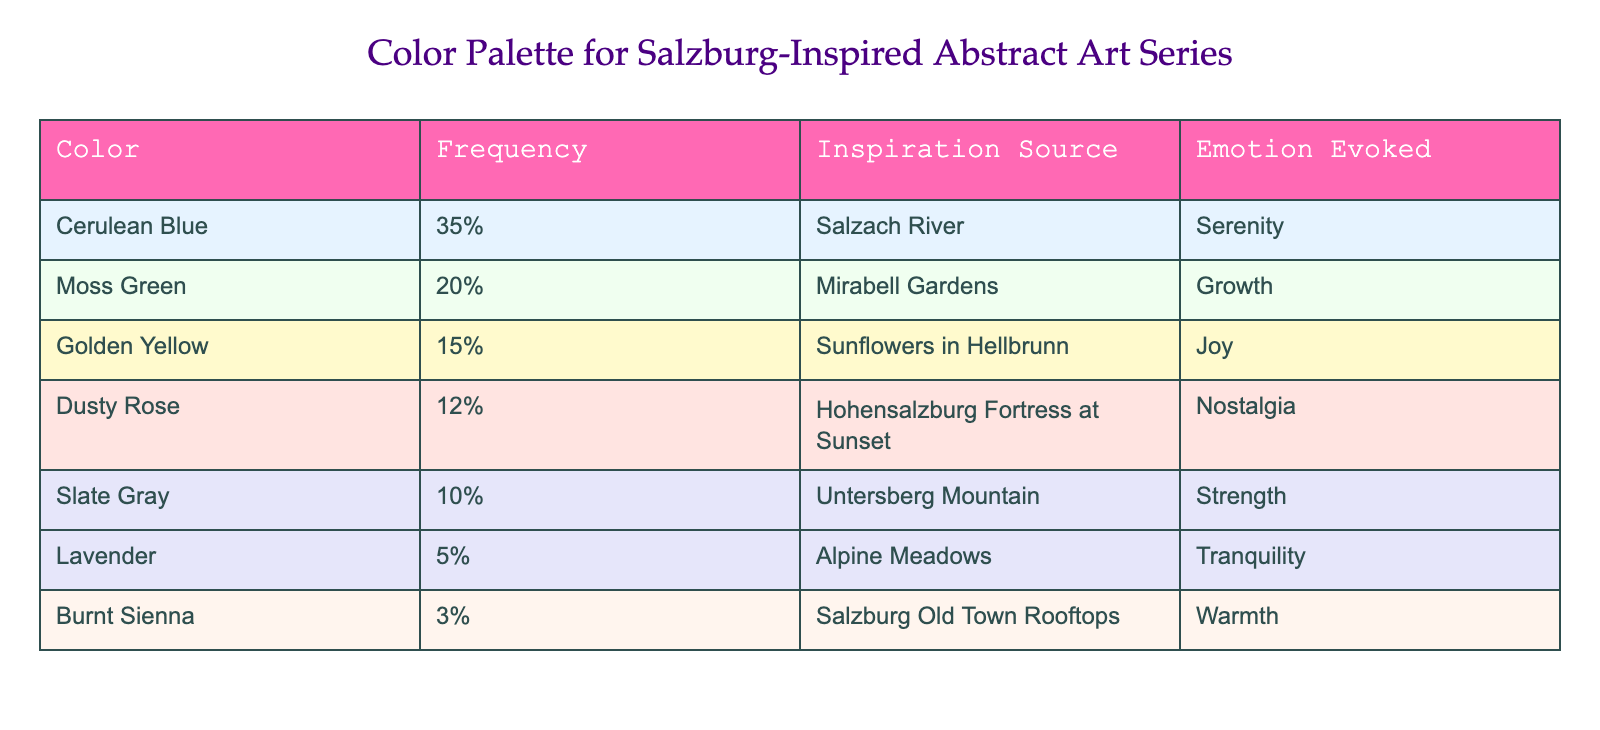What color occurs most frequently in the palette? Looking at the Frequency column, Cerulean Blue has the highest value at 35%.
Answer: Cerulean Blue What emotion is evoked by the color Moss Green? Referring to the Emotion Evoked column for Moss Green, it states that it evokes Growth.
Answer: Growth Is Lavender present in the color palette? Yes, the table lists Lavender as one of the colors used, with a frequency of 5%.
Answer: Yes What percentage do the colors representing nostalgia and tranquility together account for? Dusty Rose (12%) evokes Nostalgia, and Lavender (5%) evokes Tranquility. Adding these gives 12% + 5% = 17%.
Answer: 17% Which inspiration source corresponds to the color Golden Yellow? According to the table, Golden Yellow is inspired by Sunflowers in Hellbrunn.
Answer: Sunflowers in Hellbrunn What is the most commonly evoked emotion among the colors? The highest frequency is for Cerulean Blue (35%), evoking Serenity, which is the most common emotion in the palette.
Answer: Serenity How many colors evoke emotions related to nature? Moss Green, Golden Yellow, and Lavender can be associated with nature. Counting these, there are three colors: Moss Green and Lavender for growth and tranquility, while Golden Yellow reflects the sunflowers.
Answer: 3 What is the average frequency of the colors used in this series? To find the average, sum up the frequencies: 35% + 20% + 15% + 12% + 10% + 5% + 3% = 100%. There are seven colors, so the average is 100% / 7 ≈ 14.29%.
Answer: 14.29% Is there a color in the palette that evokes both warmth and nostalgia? Yes, Dusty Rose evokes Nostalgia and Burnt Sienna evokes Warmth. This indicates that both emotions are present in different colors, but there is no single color that evokes both.
Answer: No 